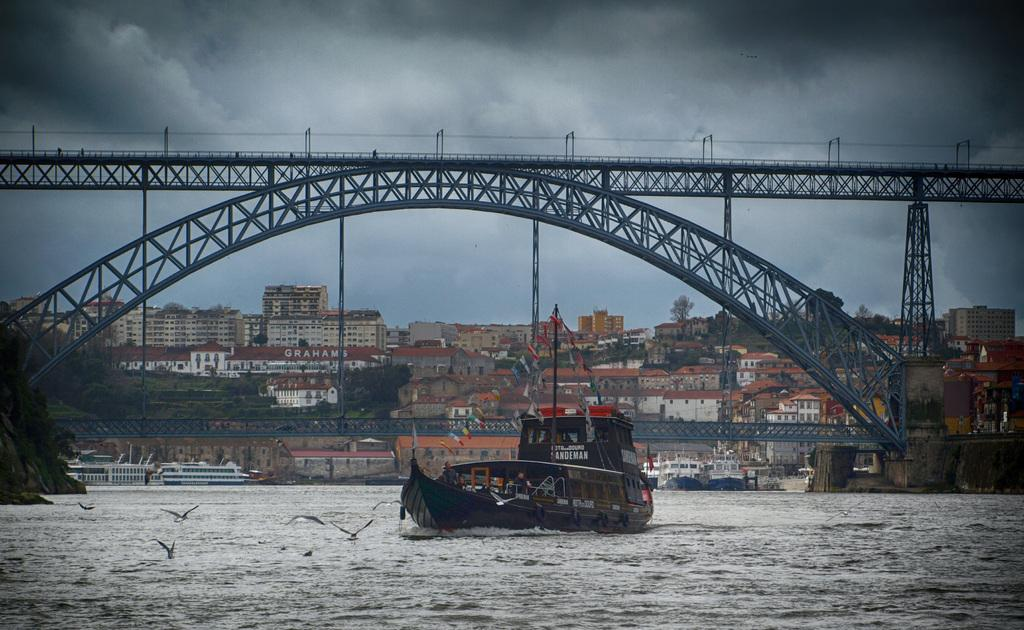What is happening in the center of the image? There are birds flying in the center of the image. What can be seen on the water in the image? There is a boat in the image. What is visible in the background of the image? The sky, clouds, trees, buildings, and water are visible in the background of the image. Are there any other boats in the image? Yes, there are boats in the background of the image. What structure can be seen connecting two areas in the background of the image? There is a bridge in the background of the image. Where is the cactus located in the image? There is no cactus present in the image. What type of fuel is being used by the birds to fly in the image? Birds do not use fuel to fly; they have their own biological mechanisms for flight. 